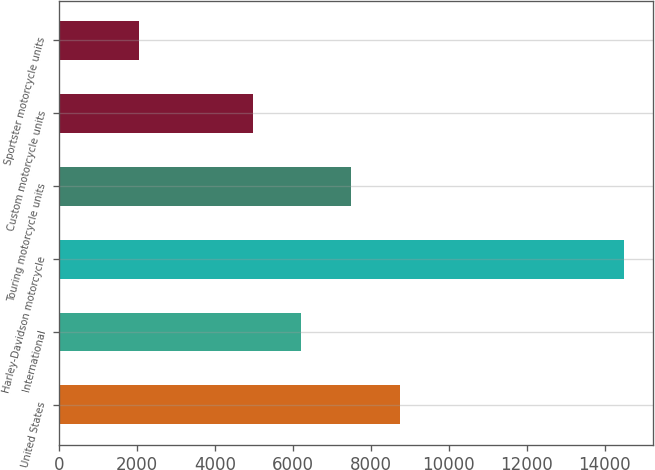Convert chart. <chart><loc_0><loc_0><loc_500><loc_500><bar_chart><fcel>United States<fcel>International<fcel>Harley-Davidson motorcycle<fcel>Touring motorcycle units<fcel>Custom motorcycle units<fcel>Sportster motorcycle units<nl><fcel>8740<fcel>6212<fcel>14508<fcel>7494<fcel>4966<fcel>2048<nl></chart> 